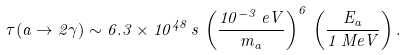Convert formula to latex. <formula><loc_0><loc_0><loc_500><loc_500>\tau ( a \to 2 \gamma ) \sim 6 . 3 \times 1 0 ^ { 4 8 } \, s \, \left ( \frac { 1 0 ^ { - 3 } \, e V } { m _ { a } } \right ) ^ { 6 } \, \left ( \frac { E _ { a } } { 1 \, M e V } \right ) .</formula> 